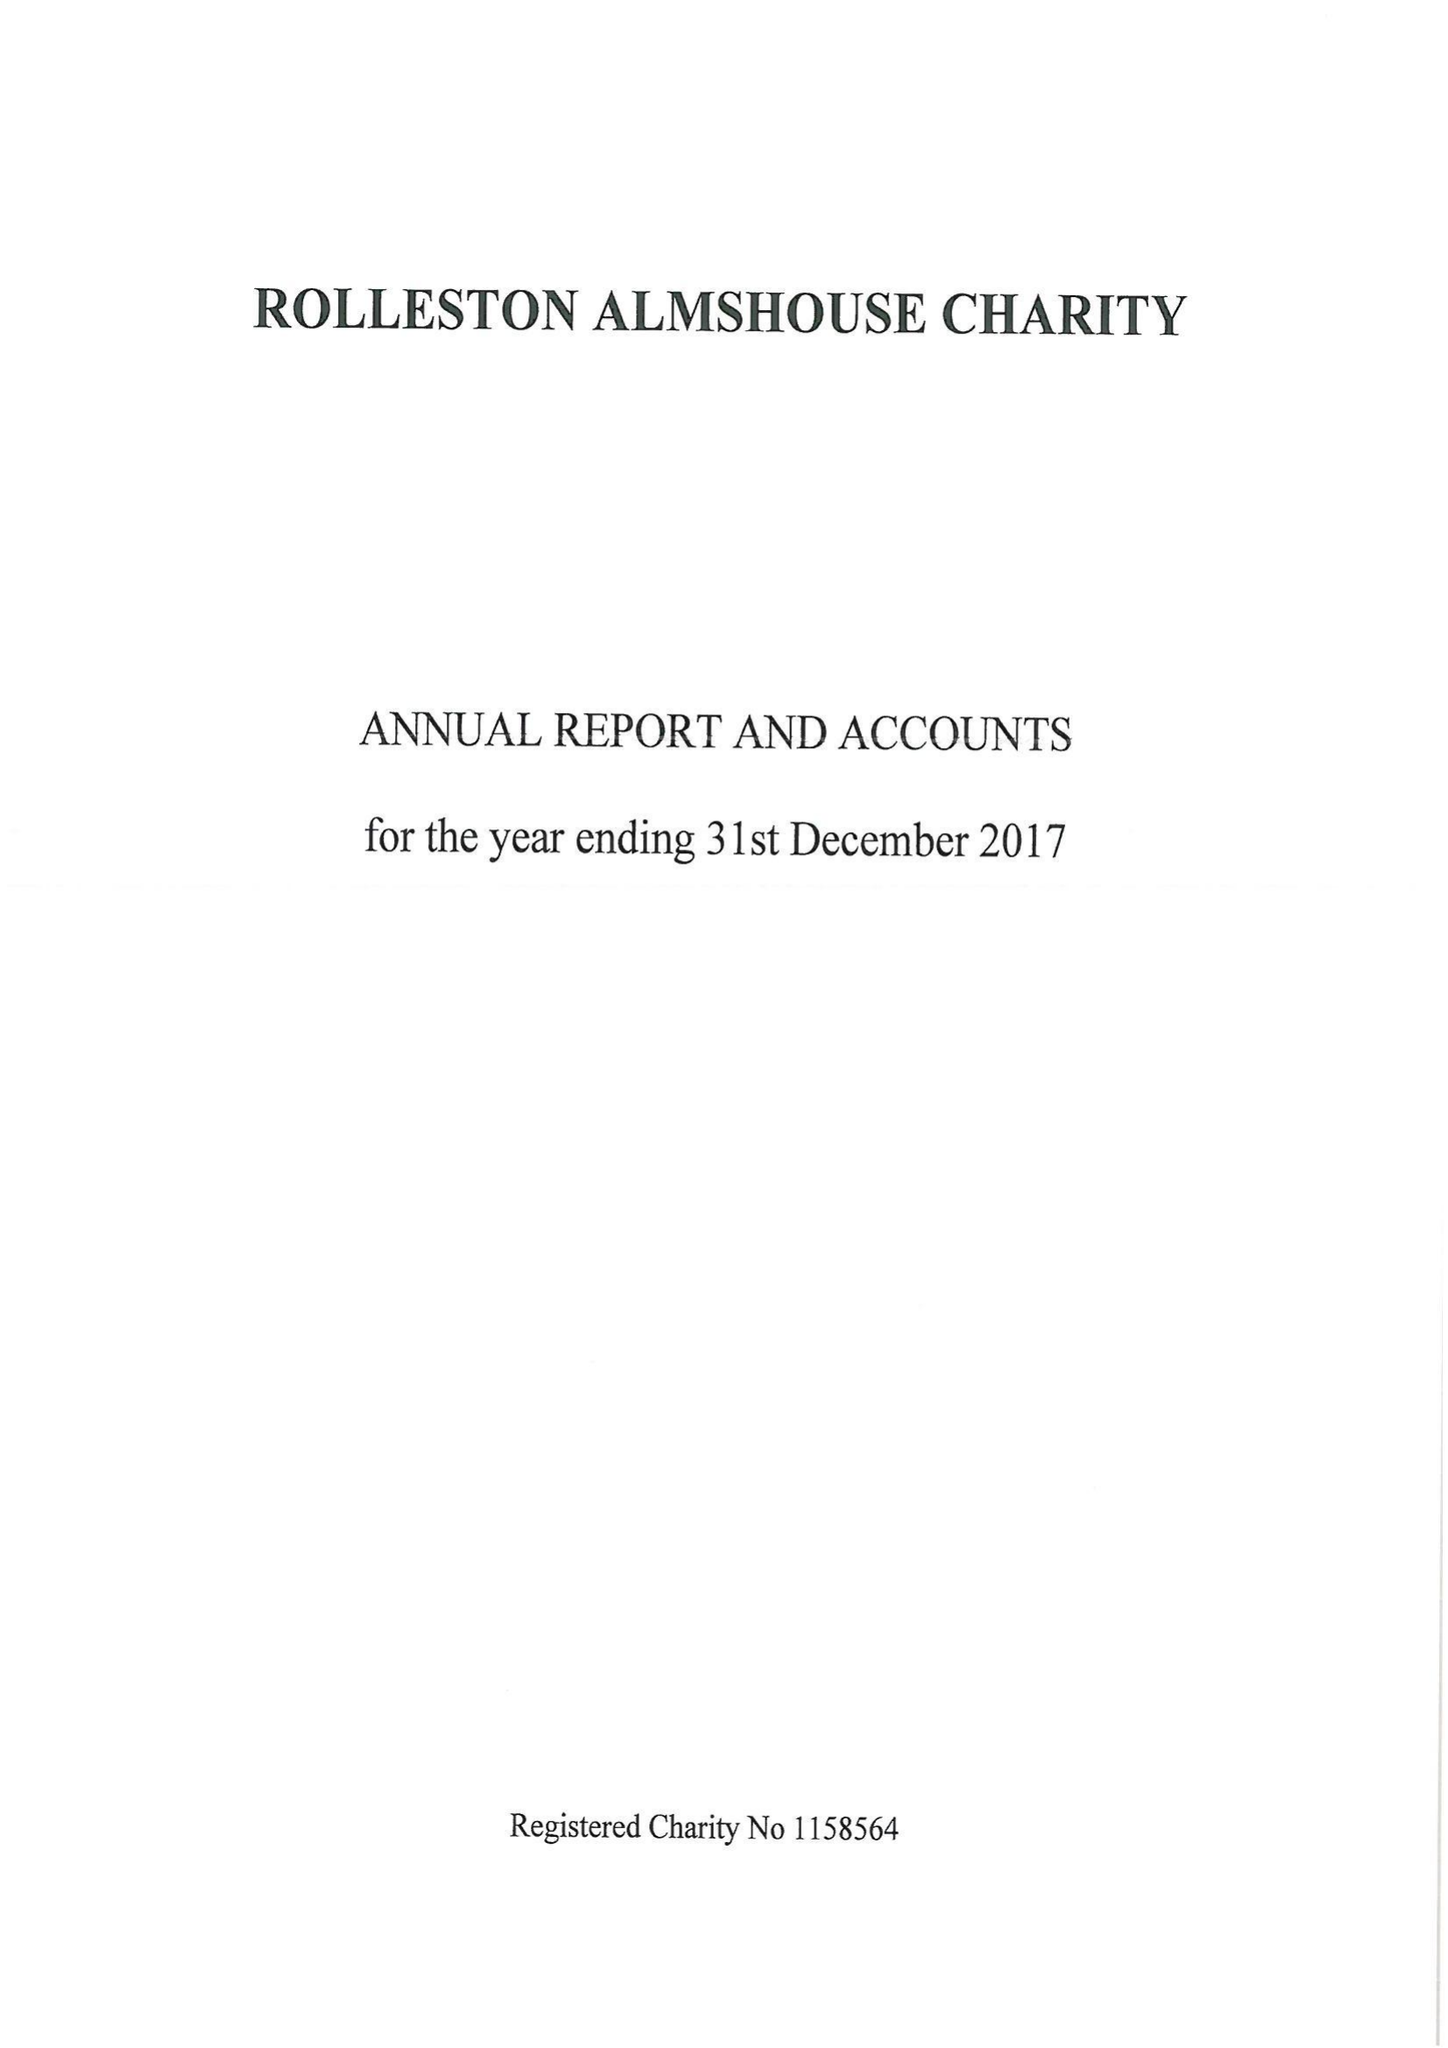What is the value for the report_date?
Answer the question using a single word or phrase. 2017-12-31 